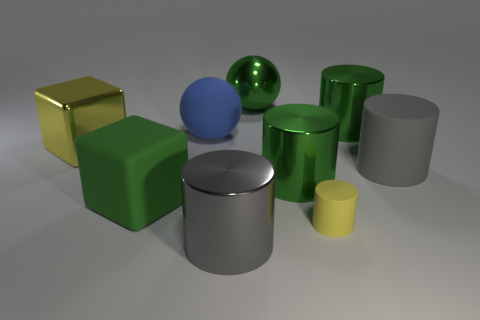Subtract all tiny yellow cylinders. How many cylinders are left? 4 Subtract all yellow cylinders. How many cylinders are left? 4 Subtract all cubes. How many objects are left? 7 Add 4 big green cylinders. How many big green cylinders exist? 6 Subtract 0 brown blocks. How many objects are left? 9 Subtract 2 cubes. How many cubes are left? 0 Subtract all yellow cubes. Subtract all gray cylinders. How many cubes are left? 1 Subtract all gray cylinders. How many cyan blocks are left? 0 Subtract all big blocks. Subtract all small yellow rubber cylinders. How many objects are left? 6 Add 4 yellow cylinders. How many yellow cylinders are left? 5 